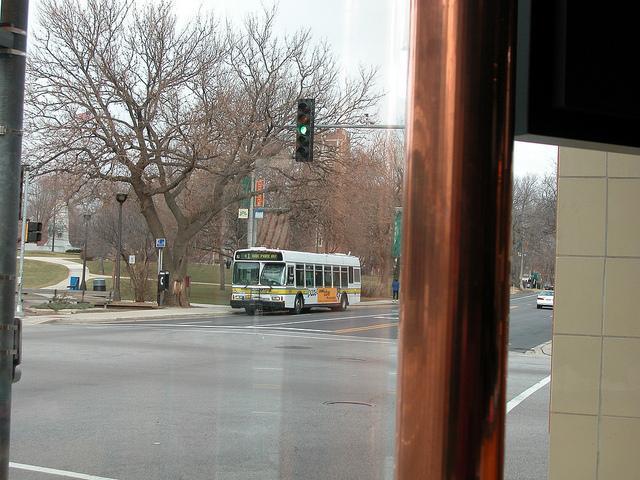How many buses are there?
Give a very brief answer. 1. How many lamp posts are there?
Give a very brief answer. 2. 